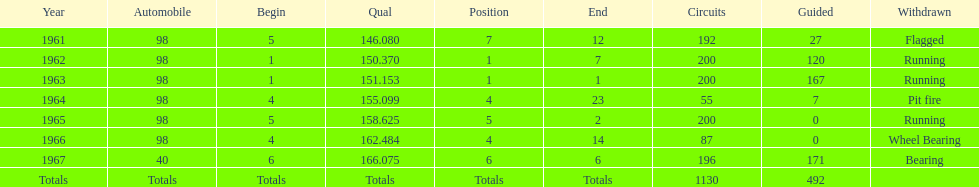How many consecutive years did parnelli place in the top 5? 5. 